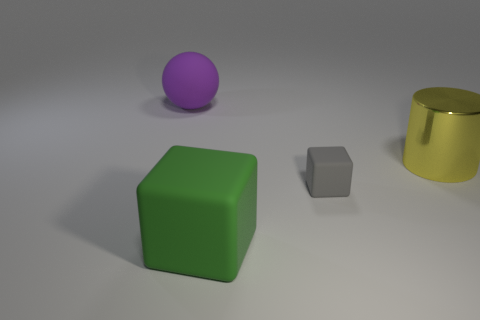What materials do the objects in the image appear to be made from? The green and gray objects in the image appear to be made of a matte material, possibly a type of plastic or rubber. The purple object seems to have a rubber-like texture, and the yellow object has a reflective surface, indicating it might be metallic, possibly gold or brass with a polished finish. 